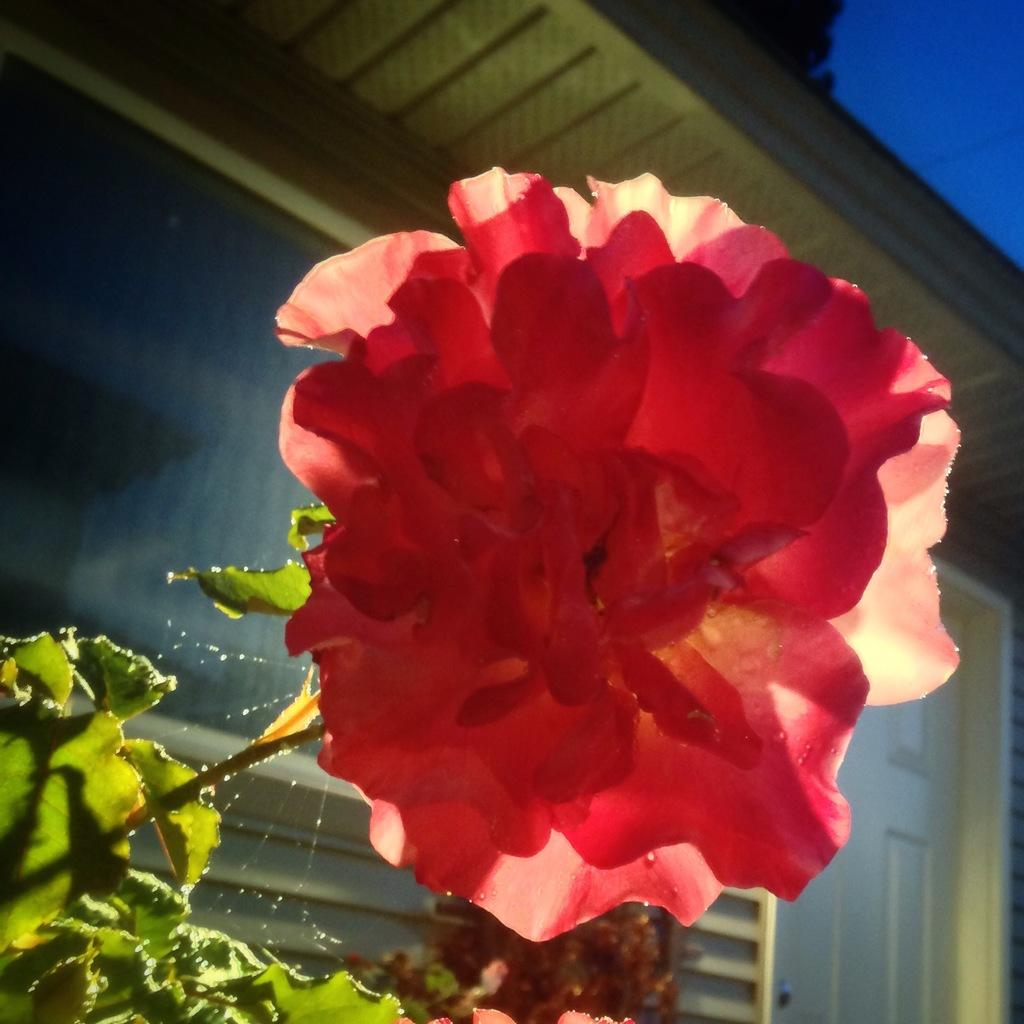What type of plant is visible in the image? There is a plant with a flower in the image. Where are the leaves located in the image? The leaves are on the left corner of the image. What structure can be seen on the right corner of the image? There is a door on the right corner of the image. What is at the top of the image? There is a roof at the top of the image. What type of ink is used to draw the flower on the plant in the image? There is no ink present in the image, as it is a photograph of a real plant with a flower. How many snakes are visible in the image? There are no snakes present in the image. 